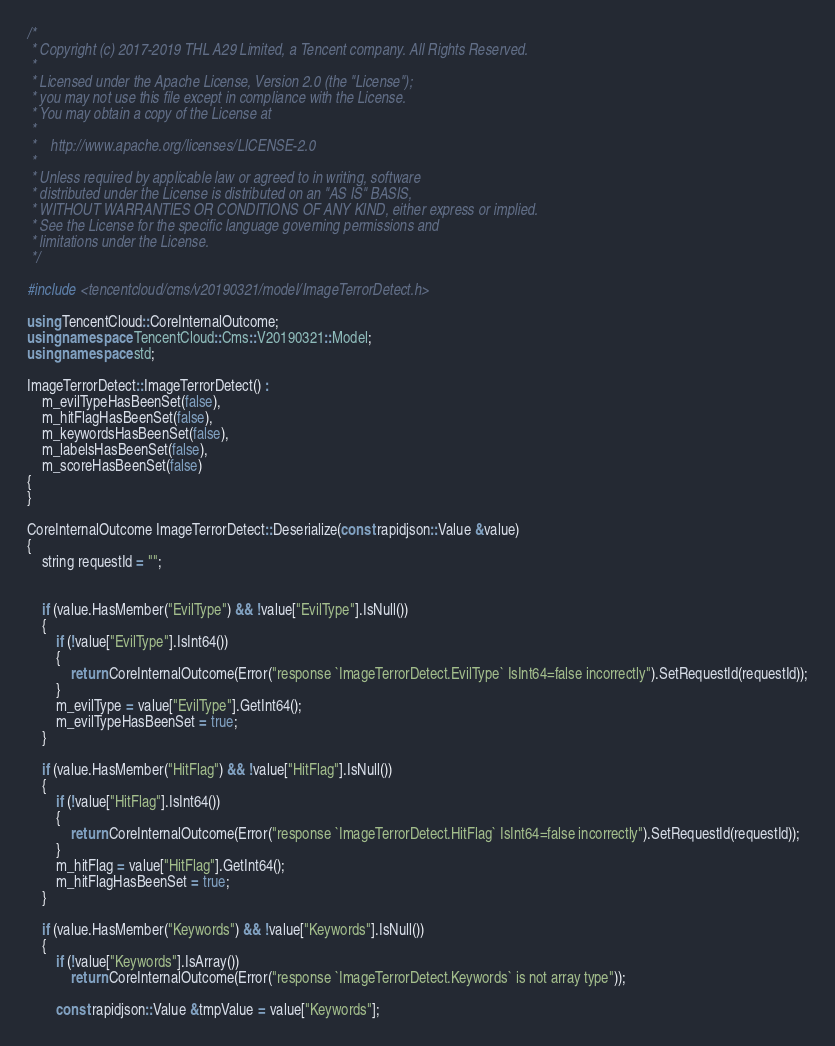<code> <loc_0><loc_0><loc_500><loc_500><_C++_>/*
 * Copyright (c) 2017-2019 THL A29 Limited, a Tencent company. All Rights Reserved.
 *
 * Licensed under the Apache License, Version 2.0 (the "License");
 * you may not use this file except in compliance with the License.
 * You may obtain a copy of the License at
 *
 *    http://www.apache.org/licenses/LICENSE-2.0
 *
 * Unless required by applicable law or agreed to in writing, software
 * distributed under the License is distributed on an "AS IS" BASIS,
 * WITHOUT WARRANTIES OR CONDITIONS OF ANY KIND, either express or implied.
 * See the License for the specific language governing permissions and
 * limitations under the License.
 */

#include <tencentcloud/cms/v20190321/model/ImageTerrorDetect.h>

using TencentCloud::CoreInternalOutcome;
using namespace TencentCloud::Cms::V20190321::Model;
using namespace std;

ImageTerrorDetect::ImageTerrorDetect() :
    m_evilTypeHasBeenSet(false),
    m_hitFlagHasBeenSet(false),
    m_keywordsHasBeenSet(false),
    m_labelsHasBeenSet(false),
    m_scoreHasBeenSet(false)
{
}

CoreInternalOutcome ImageTerrorDetect::Deserialize(const rapidjson::Value &value)
{
    string requestId = "";


    if (value.HasMember("EvilType") && !value["EvilType"].IsNull())
    {
        if (!value["EvilType"].IsInt64())
        {
            return CoreInternalOutcome(Error("response `ImageTerrorDetect.EvilType` IsInt64=false incorrectly").SetRequestId(requestId));
        }
        m_evilType = value["EvilType"].GetInt64();
        m_evilTypeHasBeenSet = true;
    }

    if (value.HasMember("HitFlag") && !value["HitFlag"].IsNull())
    {
        if (!value["HitFlag"].IsInt64())
        {
            return CoreInternalOutcome(Error("response `ImageTerrorDetect.HitFlag` IsInt64=false incorrectly").SetRequestId(requestId));
        }
        m_hitFlag = value["HitFlag"].GetInt64();
        m_hitFlagHasBeenSet = true;
    }

    if (value.HasMember("Keywords") && !value["Keywords"].IsNull())
    {
        if (!value["Keywords"].IsArray())
            return CoreInternalOutcome(Error("response `ImageTerrorDetect.Keywords` is not array type"));

        const rapidjson::Value &tmpValue = value["Keywords"];</code> 